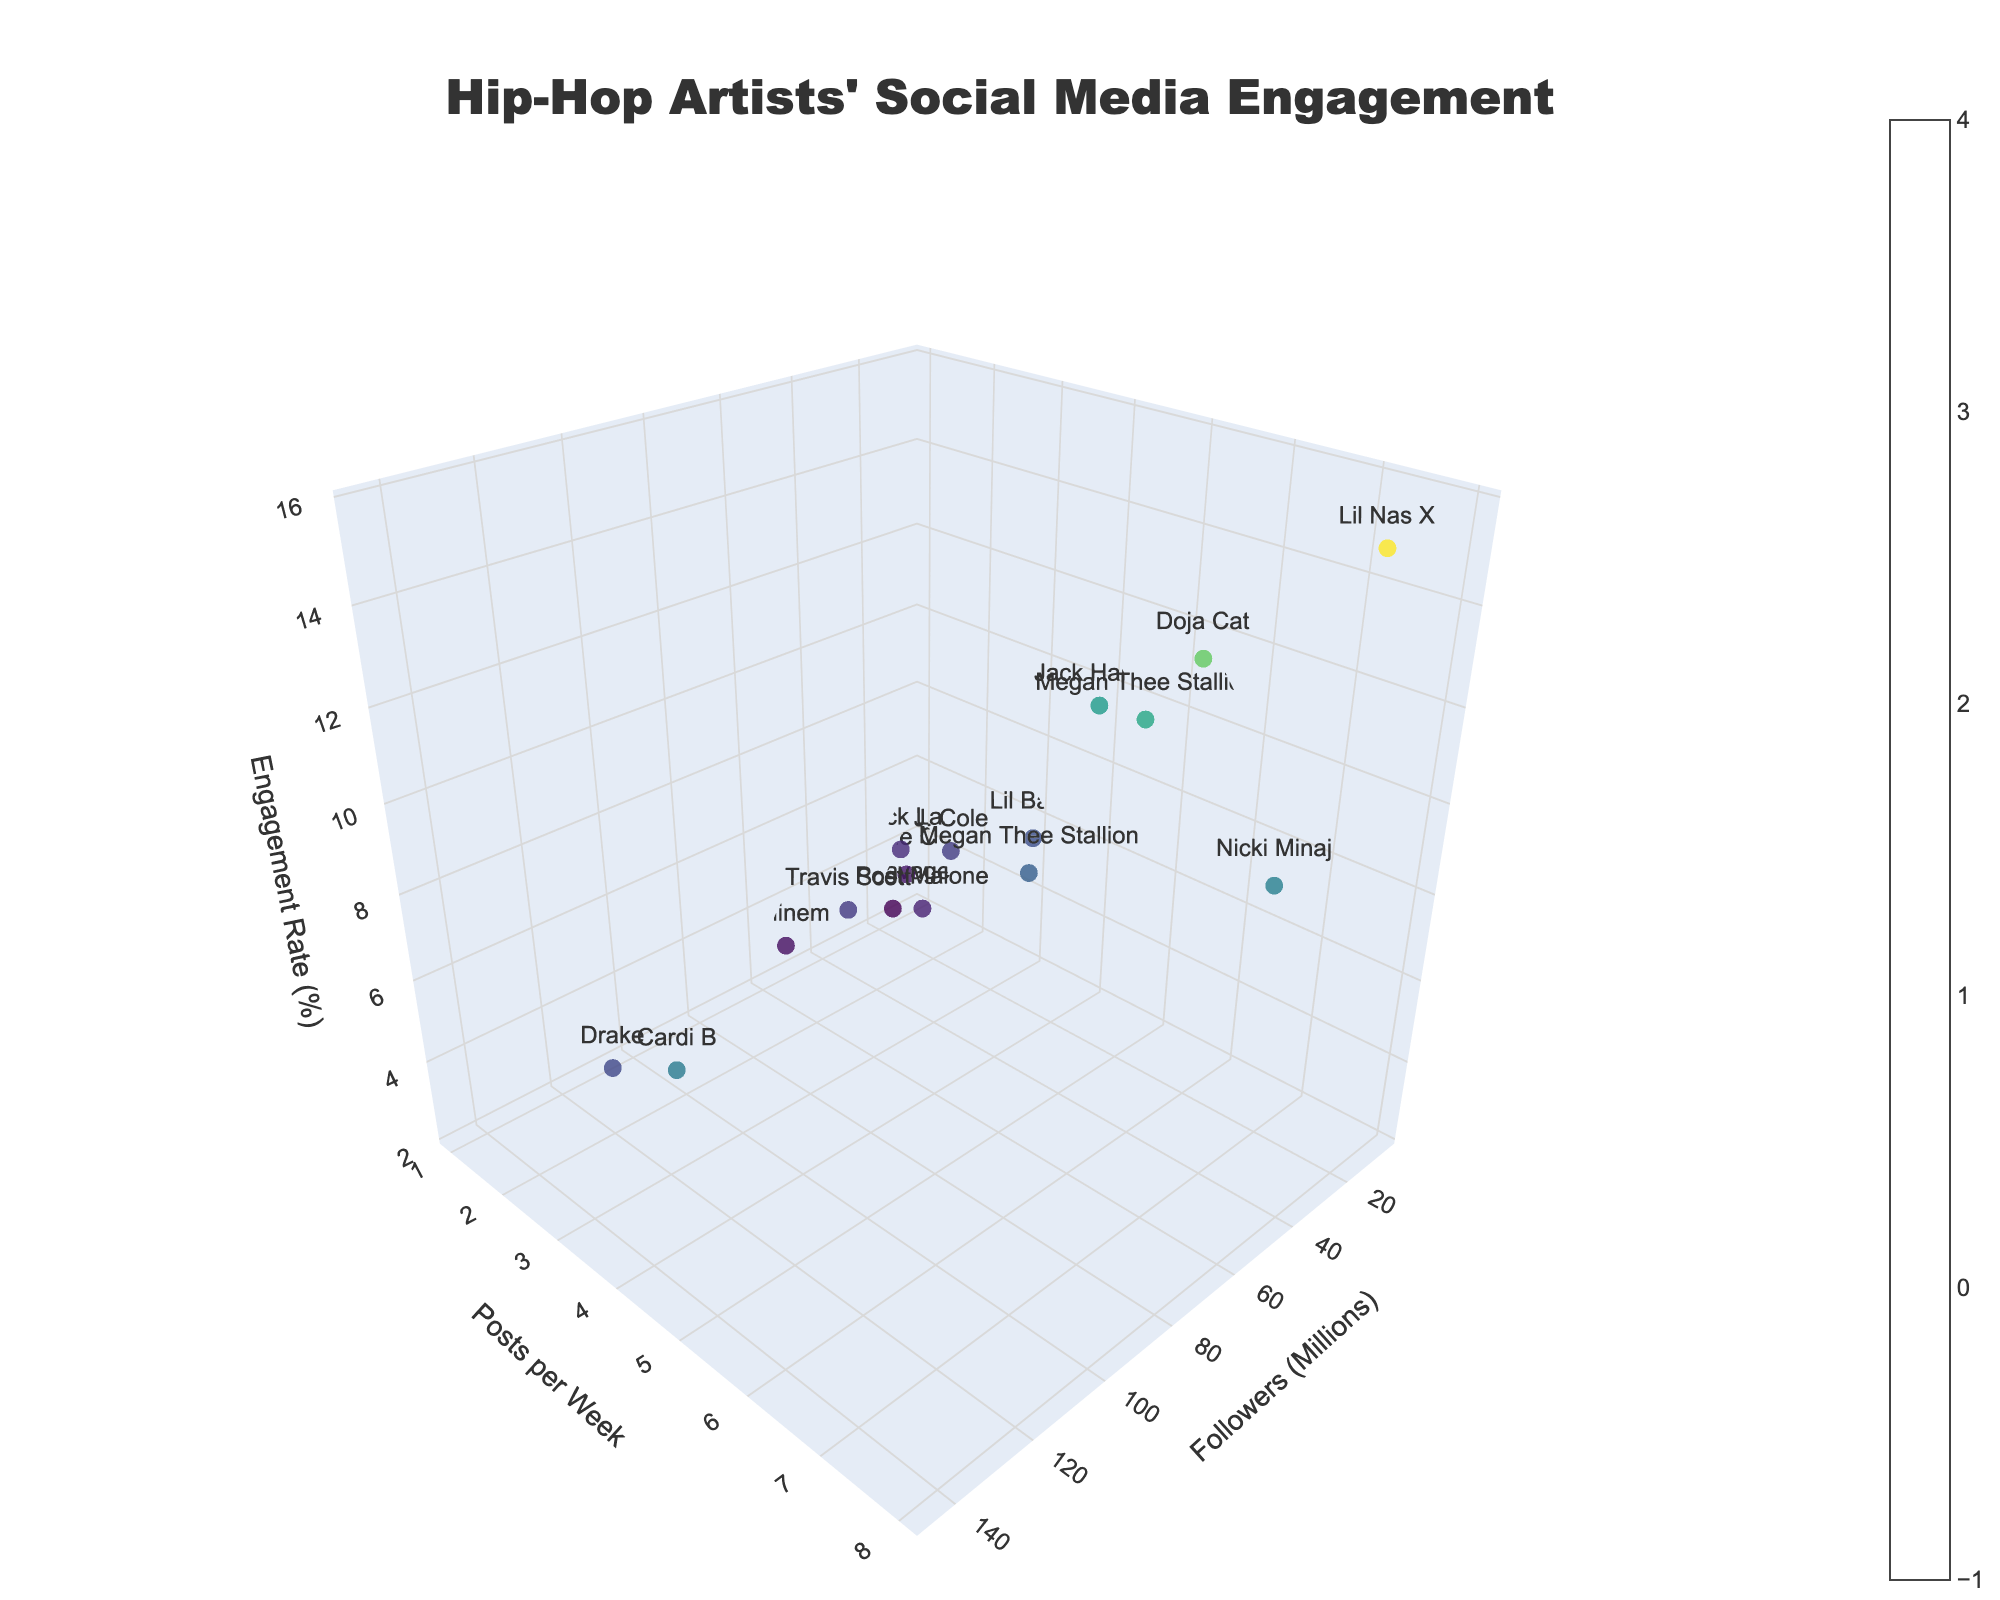What is the title of the plot? The title is displayed at the top center of the figure and reads "Hip-Hop Artists' Social Media Engagement".
Answer: Hip-Hop Artists' Social Media Engagement Which artist has the highest engagement rate on TikTok? On the plot, look at the engagement rate (z-axis) and hover over the points for TikTok. The highest engagement rate on TikTok is attributed to Lil Nas X with 15.7%.
Answer: Lil Nas X How many artists are represented from Instagram on the plot? Inspect the plot and identify the artists from Instagram by their platform label and hover text. There are four artists: Drake, Cardi B, Travis Scott, and Megan Thee Stallion.
Answer: 4 Compare Cardi B's engagement rate with Doja Cat's. Who has a higher engagement rate and by how much? Cardi B's engagement rate is 7.8% (Instagram), while Doja Cat's is 12.4% (TikTok). Subtract Cardi B's engagement rate from Doja Cat's: 12.4% - 7.8% = 4.6%.
Answer: Doja Cat, by 4.6% What is the average post frequency per week for artists on Twitter? Sum the posts per week for Twitter artists: Kendrick Lamar (1), J. Cole (2), Nicki Minaj (7), and Lil Baby (3). The total is 1 + 2 + 7 + 3 = 13. There are 4 artists, so the average is 13/4 = 3.25 posts/week.
Answer: 3.25 posts/week Which platform has the artist with the lowest engagement rate, and who is the artist? Identify the lowest engagement rate by checking the z-axis. Hover over the points to find that the lowest rate is 2.3%, attributed to 21 Savage on YouTube.
Answer: YouTube, 21 Savage Are there more artists with over 100 million followers on Instagram or TikTok? Hover over the points to check the follower count for each platform. On Instagram, two artists (Drake and Cardi B) have over 100 million followers, while no one on TikTok exceeds 100 million followers.
Answer: Instagram Between Post Malone and Tyler The Creator, who posts more frequently on YouTube? Hover over both artists' data points. Post Malone posts twice per week, while Tyler The Creator posts once per week.
Answer: Post Malone What is the overall distribution pattern of engagement rates observed in the plot? Engagement rates vary widely, from as low as 2.3% to as high as 15.7%. Generally, TikTok appears to have higher engagement rates, while YouTube has lower overall engagement rates.
Answer: Varied, TikTok higher, YouTube lower 